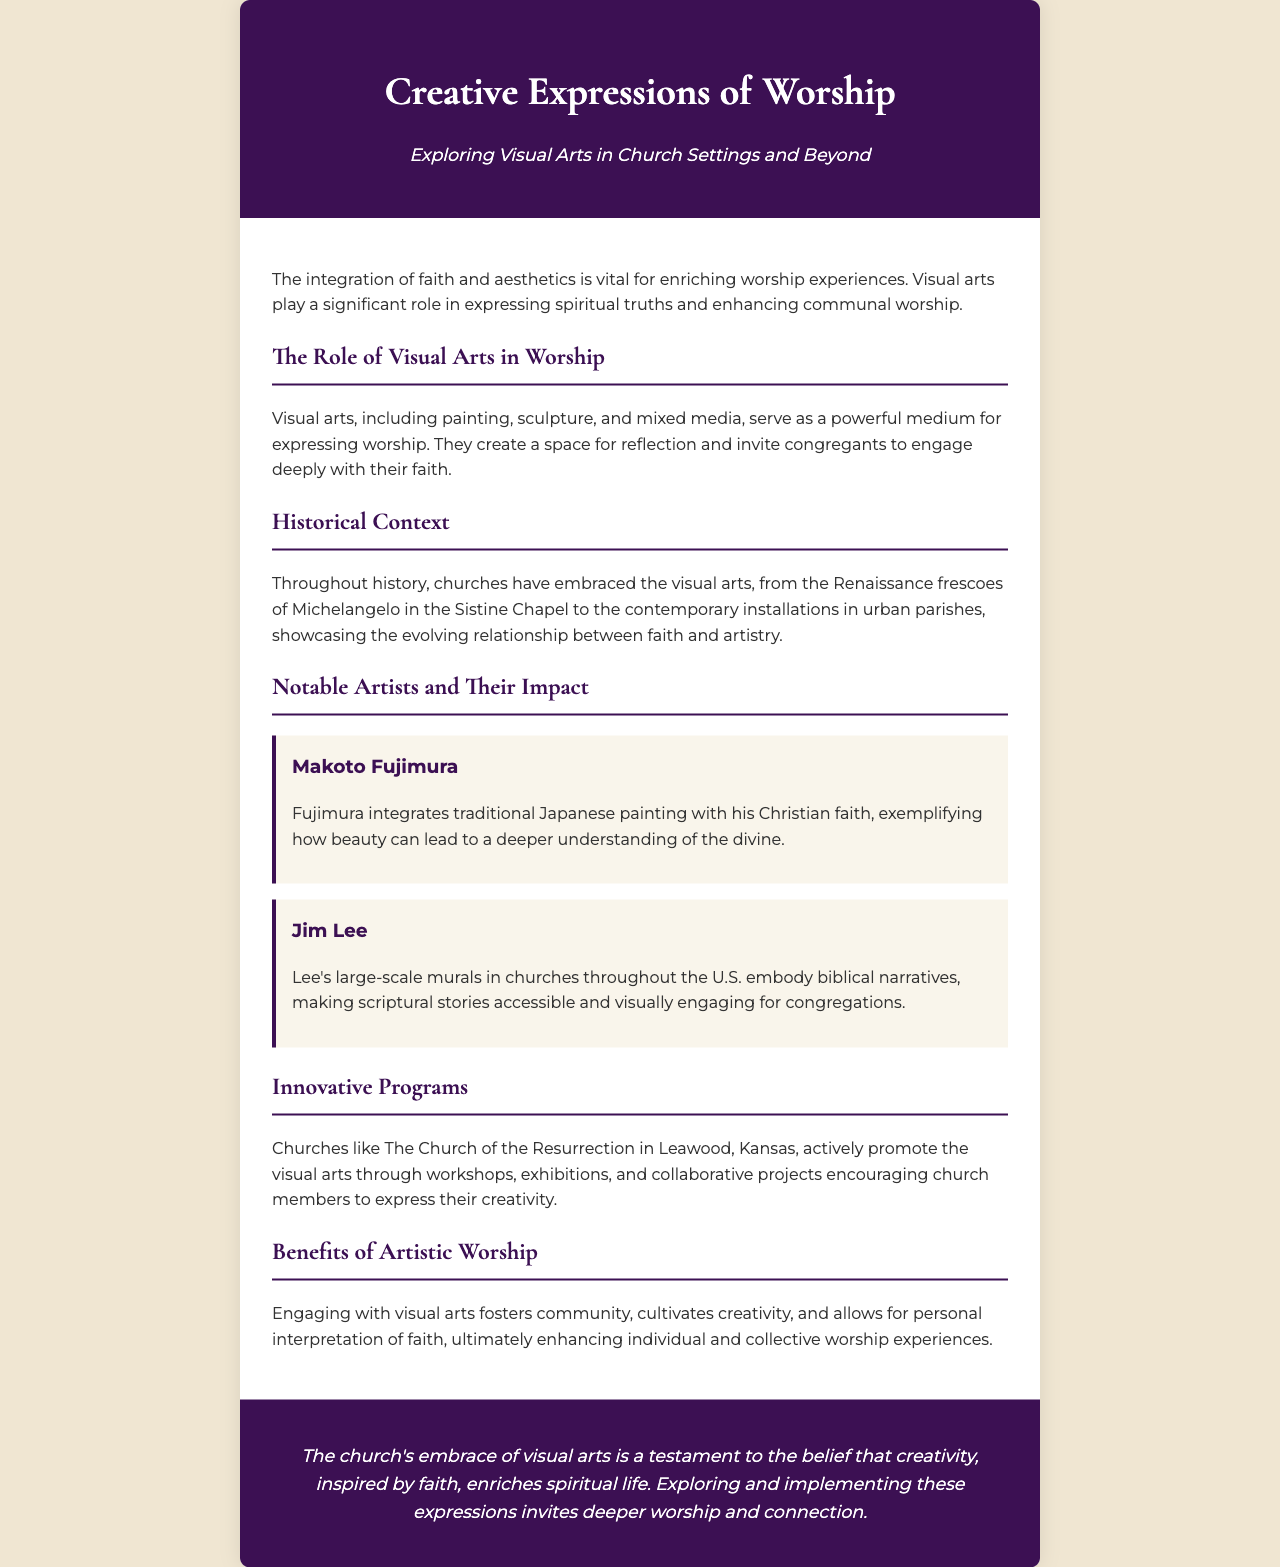What is the title of the brochure? The title is prominently displayed at the top of the brochure.
Answer: Creative Expressions of Worship What is the main theme presented in the introduction? The introduction highlights the integration of faith and aesthetics in worship experiences.
Answer: Integration of faith and aesthetics Who is mentioned as an artist integrating traditional Japanese painting and faith? This artist is specified in the notable artists section of the brochure.
Answer: Makoto Fujimura What historical art movement is referenced in the document? This refers to an important period mentioned in the historical context of the document.
Answer: Renaissance What type of art programs does The Church of the Resurrection promote? The brochure describes the types of initiatives taken by this church.
Answer: Workshops, exhibitions, and collaborative projects How does engaging with visual arts benefit worship? This benefit is specifically discussed in a section dedicated to the positive aspects of artistic worship.
Answer: Fosters community What color is the header background? The specific color of the header is noted in the design details of the document.
Answer: Dark purple What is the concluding statement's emphasis? The conclusion summarizes a key belief expressed earlier in the document.
Answer: Creativity, inspired by faith, enriches spiritual life 